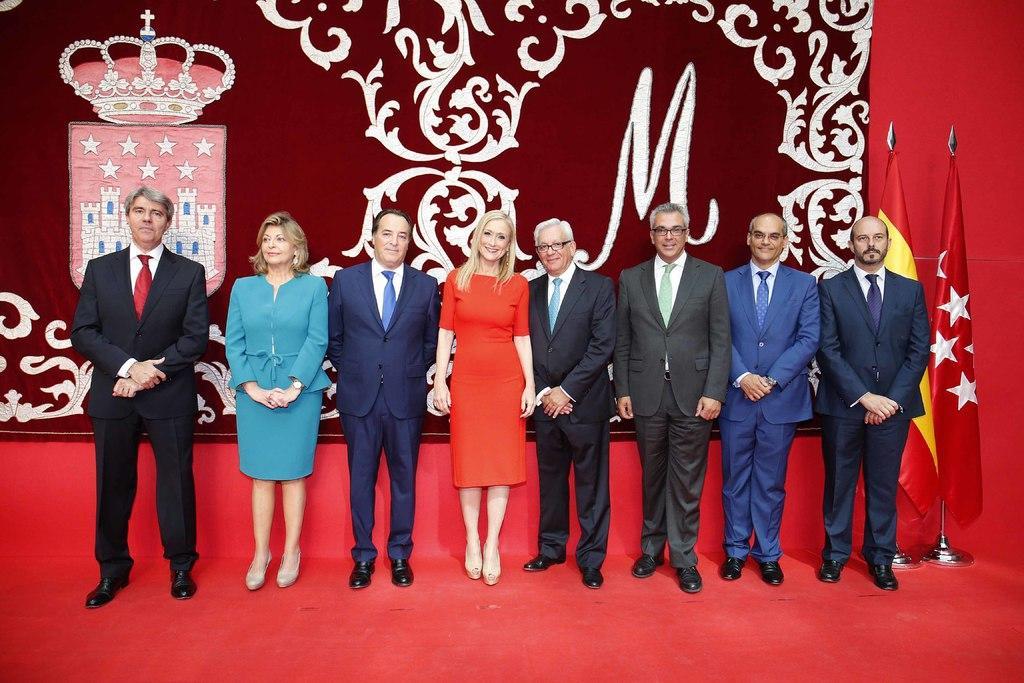In one or two sentences, can you explain what this image depicts? In front of the image there are people standing on the mat. On the right side of the image there are flags. In the background of the image there is a curtain with some design and crown on it. 